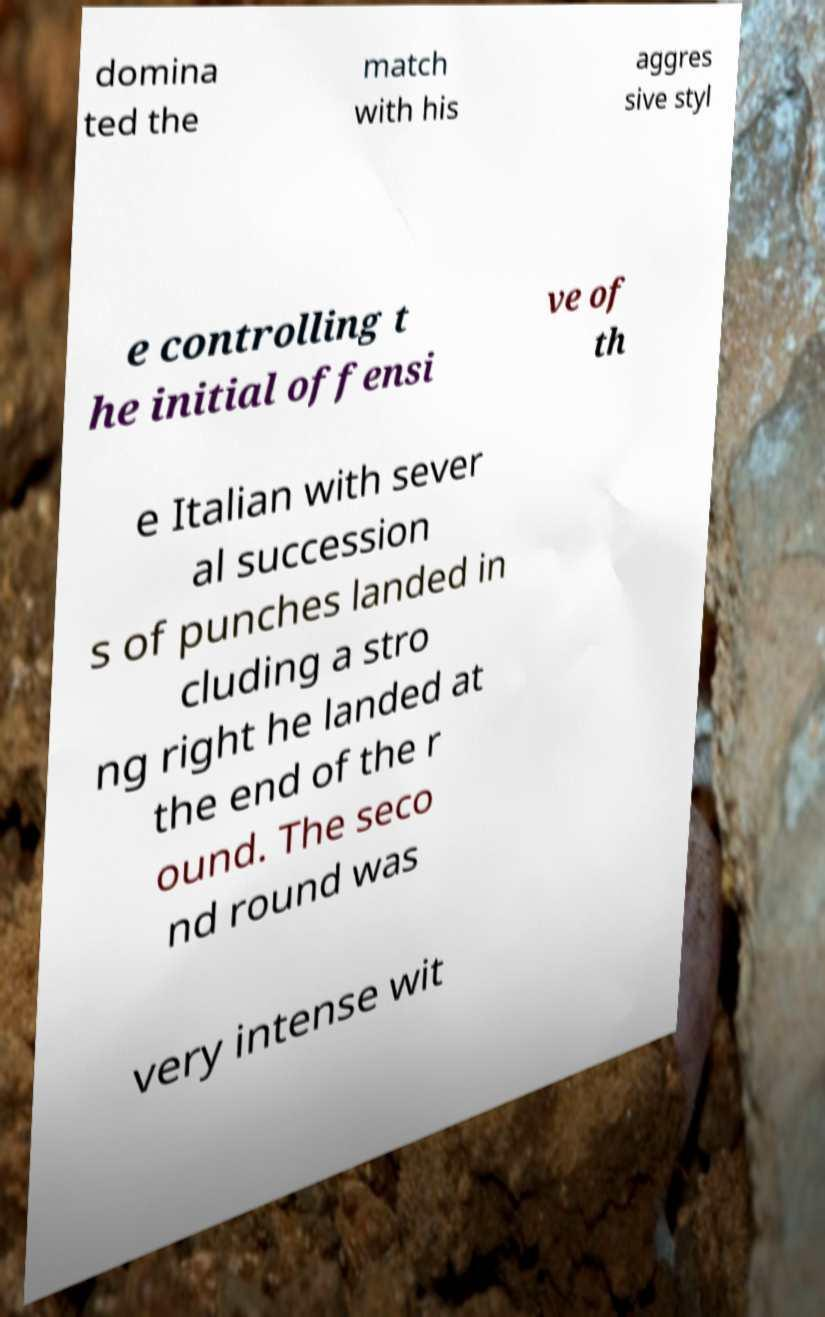I need the written content from this picture converted into text. Can you do that? domina ted the match with his aggres sive styl e controlling t he initial offensi ve of th e Italian with sever al succession s of punches landed in cluding a stro ng right he landed at the end of the r ound. The seco nd round was very intense wit 